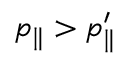<formula> <loc_0><loc_0><loc_500><loc_500>p _ { \| } > p _ { \| } ^ { \prime }</formula> 